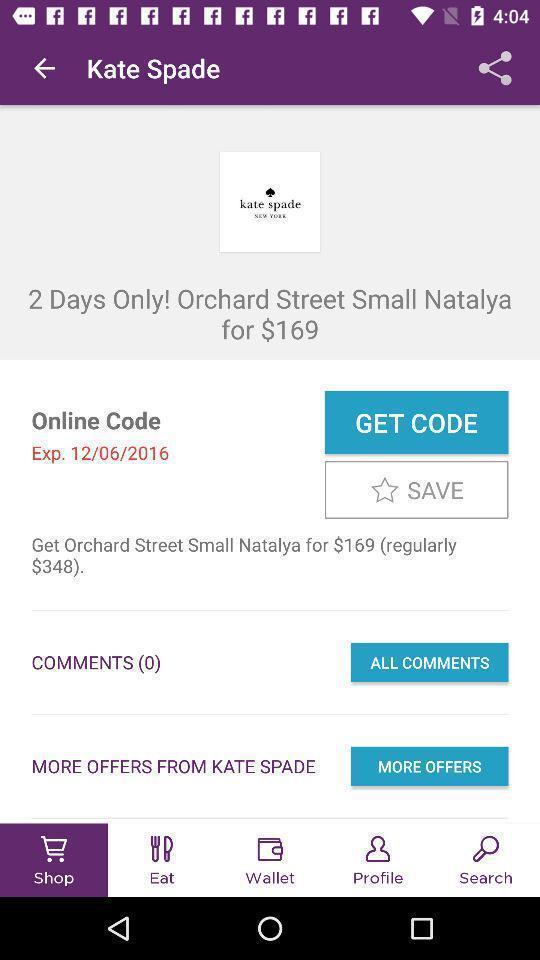Describe this image in words. Screen displaying screen page. 